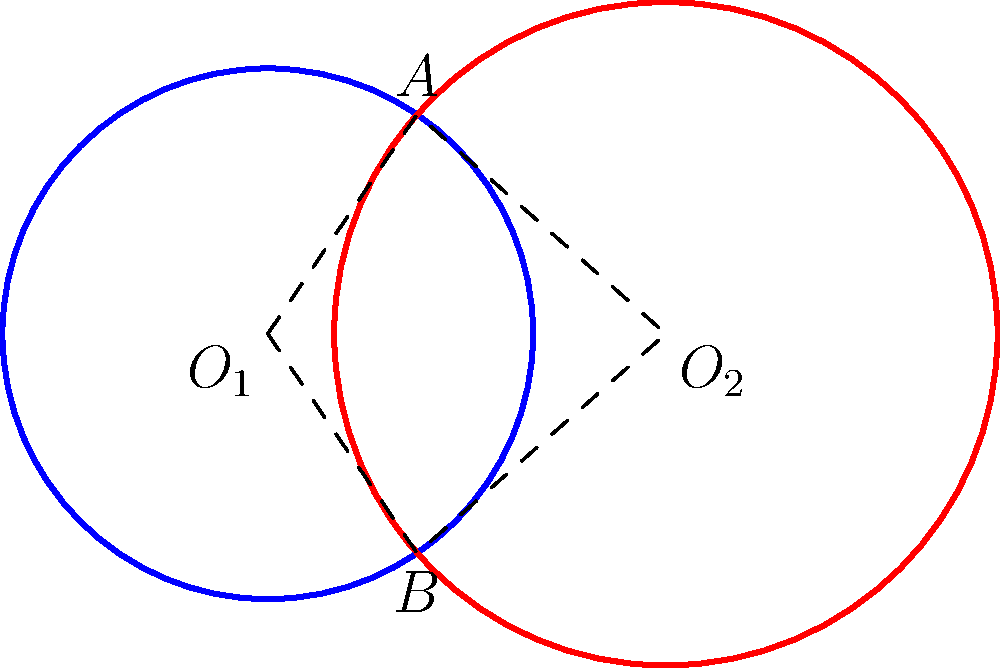Two circles represent different cultural influences in your life. The blue circle centered at $O_1$ has a radius of 2 units, while the red circle centered at $O_2$ has a radius of 2.5 units. The distance between their centers is 3 units. Calculate the area of the quadrilateral $O_1AO_2B$, where $A$ and $B$ are the intersection points of the circles. This area represents the blending of your dual cultural identity. Let's approach this step-by-step:

1) First, we need to find the height of the triangle $O_1AO_2$. We can do this using the Pythagorean theorem.

2) Let $h$ be the height of the triangle. Then:

   $h^2 + (\frac{3}{2})^2 = 2^2$

3) Solving for $h$:

   $h^2 = 4 - \frac{9}{4} = \frac{7}{4}$
   $h = \frac{\sqrt{7}}{2}$

4) The area of triangle $O_1AO_2$ is:

   $Area_{O_1AO_2} = \frac{1}{2} * 3 * \frac{\sqrt{7}}{2} = \frac{3\sqrt{7}}{4}$

5) The quadrilateral $O_1AO_2B$ consists of two congruent triangles (due to symmetry), so its area is twice the area of triangle $O_1AO_2$.

6) Therefore, the area of quadrilateral $O_1AO_2B$ is:

   $Area_{O_1AO_2B} = 2 * \frac{3\sqrt{7}}{4} = \frac{3\sqrt{7}}{2}$

This area represents the intersection of your cultural influences, symbolizing the unique space where your dual identities blend.
Answer: $\frac{3\sqrt{7}}{2}$ square units 